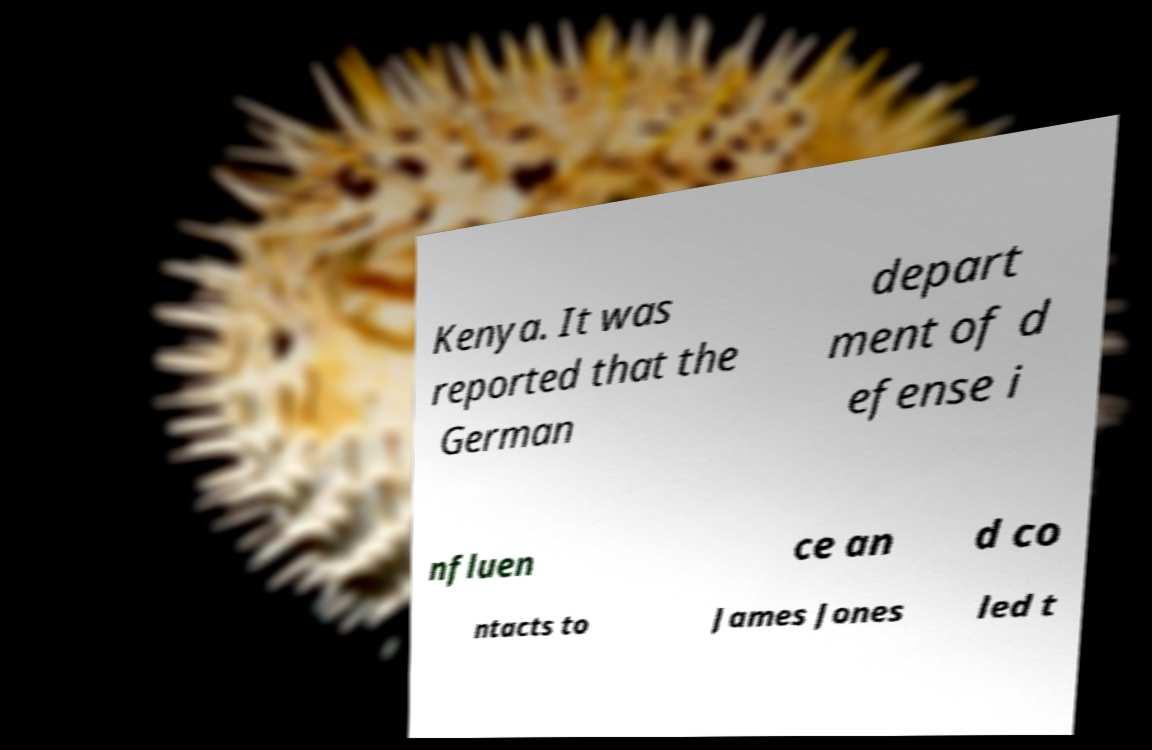What messages or text are displayed in this image? I need them in a readable, typed format. Kenya. It was reported that the German depart ment of d efense i nfluen ce an d co ntacts to James Jones led t 